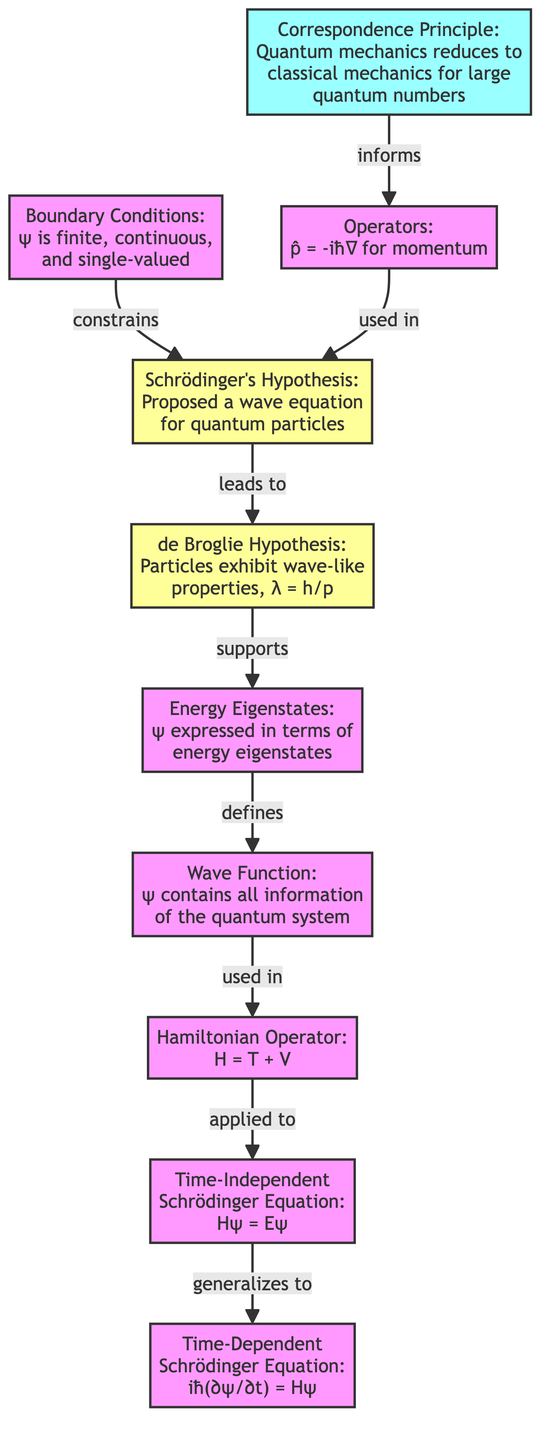What is the final form of the equation depicted in the diagram? The end node in the flowchart states the final form as "Time-Dependent Schrödinger Equation: iħ(∂ψ/∂t) = Hψ", which is a crucial result in quantum mechanics.
Answer: Time-Dependent Schrödinger Equation: iħ(∂ψ/∂t) = Hψ Which hypothesis led to the de Broglie Hypothesis in the diagram? The arrow from "Schrödinger's Hypothesis" indicates that it leads to "de Broglie Hypothesis". This suggests that the proposed wave equation by Schrödinger connects to the concept of wave-like properties of particles.
Answer: Schrödinger's Hypothesis What are the boundary conditions mentioned in the diagram? The diagram describes boundary conditions as "ψ is finite, continuous, and single-valued", indicating fundamental requirements for the wave function in quantum mechanics.
Answer: ψ is finite, continuous, and single-valued How does the Correspondence Principle relate to operators in this flowchart? The flowchart shows that "Correspondence Principle" informs the use of "Operators", which indicates that the principle relates quantum mechanics with classical mechanics, thereby affecting how operators are defined and used.
Answer: informs What is the relationship between the Hamiltonian Operator and the Time-Independent Schrödinger Equation? The diagram establishes a direct connection where the "Hamiltonian Operator" is applied to the "Time-Independent Schrödinger Equation". This suggests that the definition of the Hamiltonian is used in the formulation of the equation.
Answer: applied to How many nodes are there in total in the diagram? By counting all the unique elements listed in the data, there are ten distinct nodes, each representing a key component or concept in the derivation of the Schrödinger Equation.
Answer: ten What is the first step in the flowchart? The flowchart initiates with "Schrödinger's Hypothesis", signifying that this is the foundational assumption upon which other elements are developed.
Answer: Schrödinger's Hypothesis What does the wave function represent in the context of this diagram? The diagram states that the wave function "ψ contains all information of the quantum system", highlighting its fundamental role in describing quantum states within the framework of quantum mechanics.
Answer: ψ contains all information of the quantum system What condition must the wave function satisfy based on the diagram? The flowchart outlines boundary conditions for ψ, which means that the wave function must be finite, continuous, and single-valued to be physically meaningful in quantum mechanics.
Answer: finite, continuous, and single-valued 